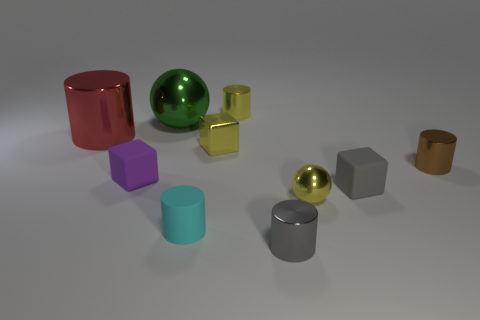Subtract 1 cylinders. How many cylinders are left? 4 Subtract all brown cylinders. How many cylinders are left? 4 Subtract all tiny matte cylinders. How many cylinders are left? 4 Subtract all green balls. Subtract all brown cylinders. How many balls are left? 1 Subtract all blocks. How many objects are left? 7 Add 10 tiny cyan rubber cubes. How many tiny cyan rubber cubes exist? 10 Subtract 0 cyan cubes. How many objects are left? 10 Subtract all tiny balls. Subtract all small purple matte blocks. How many objects are left? 8 Add 7 tiny purple things. How many tiny purple things are left? 8 